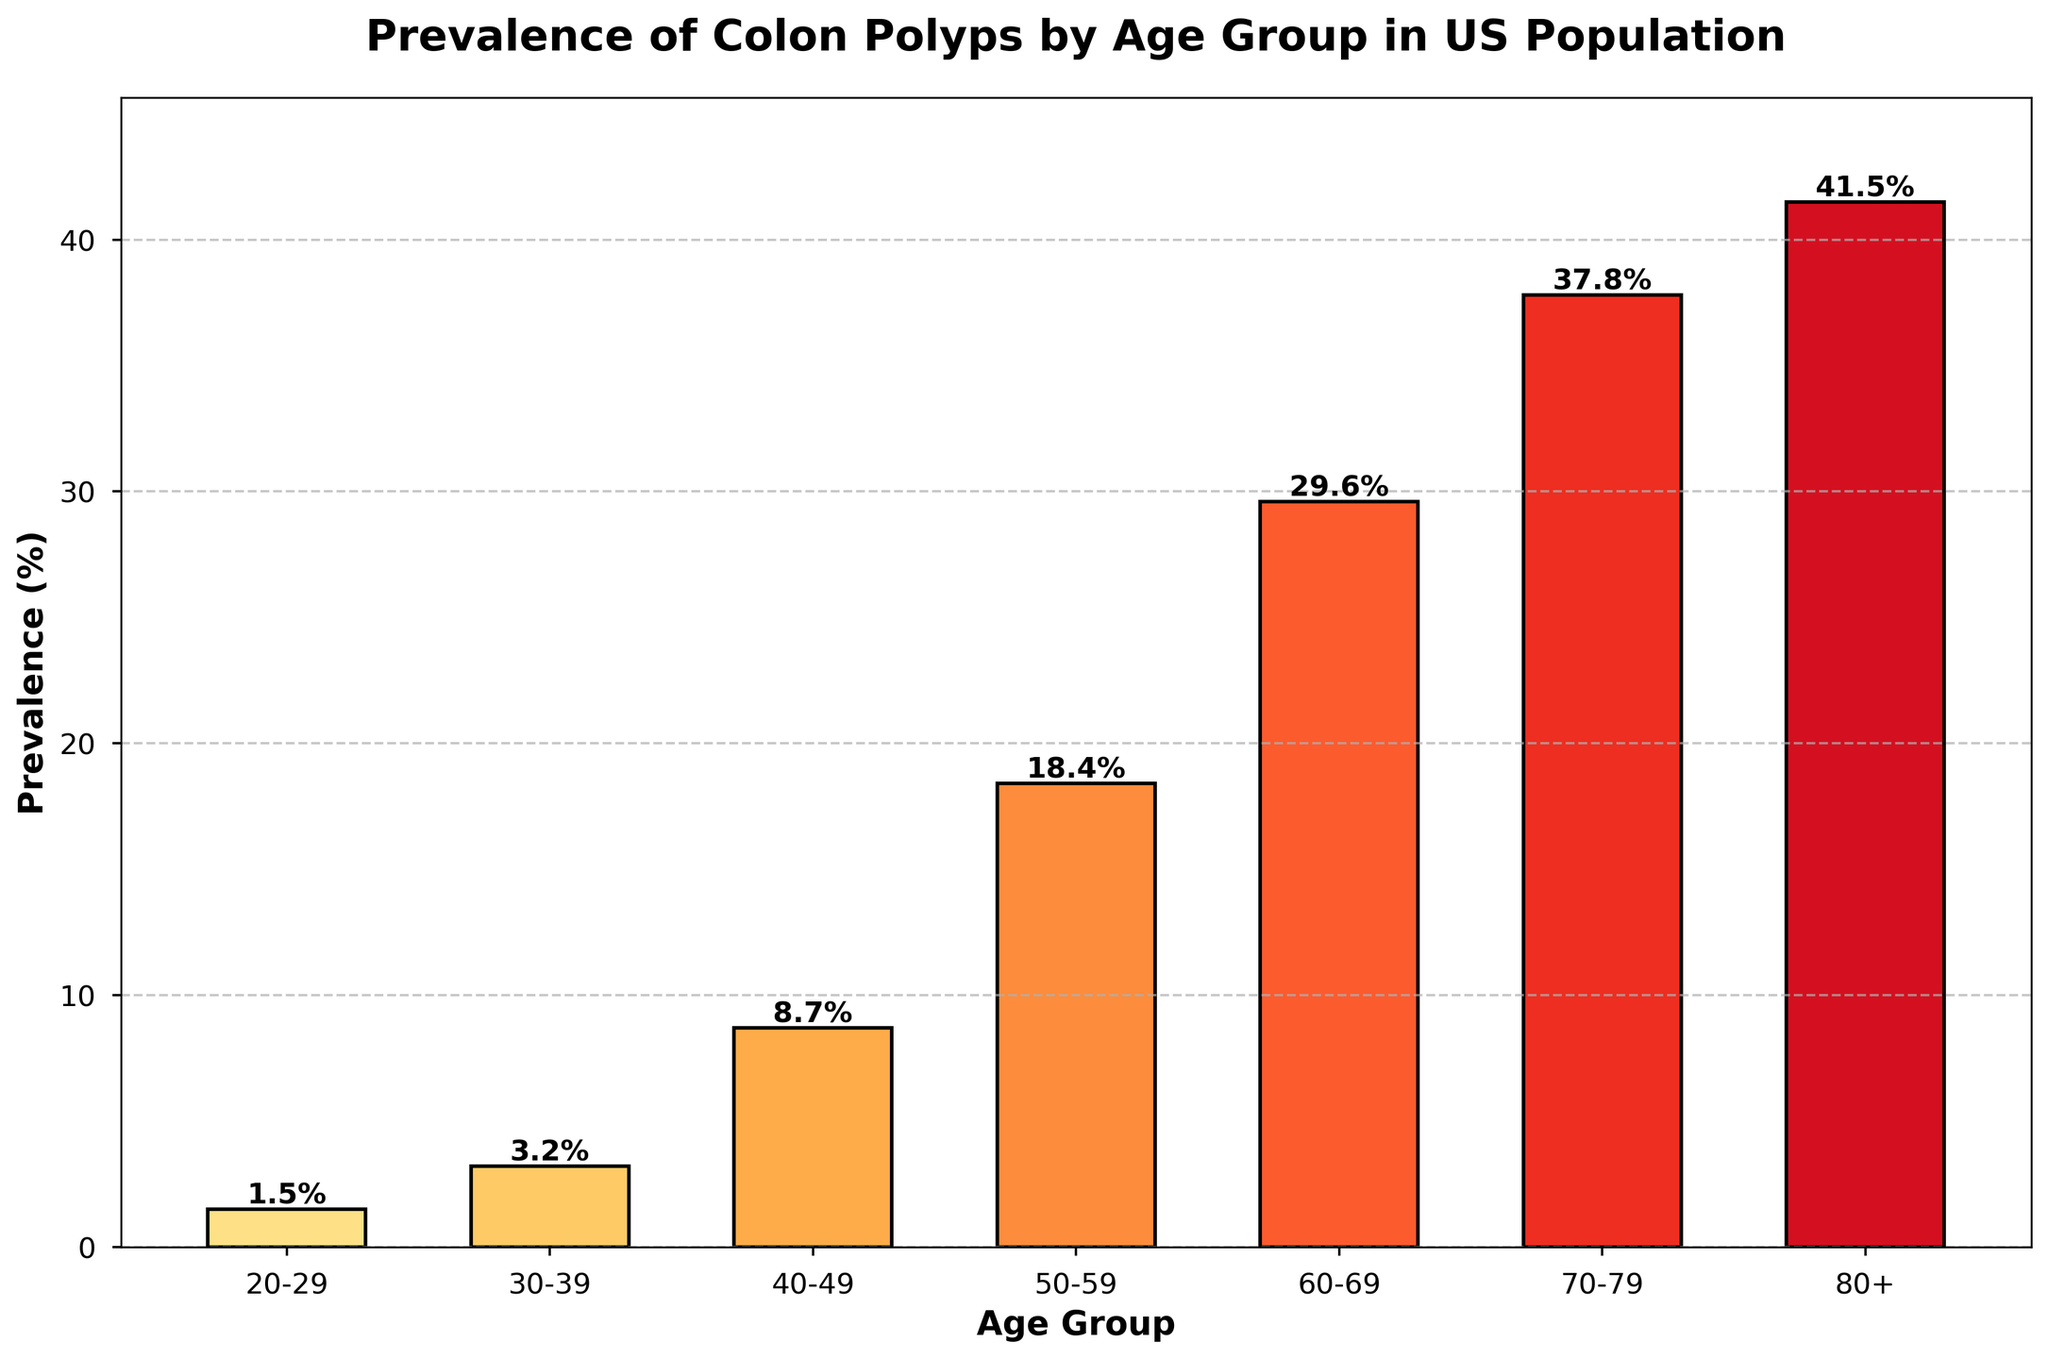What's the age group with the highest prevalence of colon polyps? The age group with the highest prevalence of colon polyps will have the tallest bar in the chart. By examining the chart, it's clear that the bar for the 80+ age group is the tallest, indicating the highest prevalence.
Answer: 80+ What's the difference in prevalence between the 40-49 and 50-59 age groups? To find the difference in prevalence, subtract the prevalence of the 40-49 age group from the 50-59 age group. The prevalence for 40-49 is 8.7%, and for 50-59, it is 18.4%. The difference is 18.4% - 8.7%.
Answer: 9.7% Which age group has a prevalence of colon polyps greater than 30%? An age group with a prevalence greater than 30% will have bars that extend above the 30% mark on the y-axis. By looking at the chart, the 70-79 and 80+ age groups have prevalence rates of 37.8% and 41.5%, respectively.
Answer: 70-79, 80+ What is the average prevalence of colon polyps for the age groups 60-69 and 70-79? To calculate the average prevalence, add the prevalence figures for the 60-69 and 70-79 age groups and divide by 2. The prevalences are 29.6% and 37.8%. The average is (29.6% + 37.8%) / 2.
Answer: 33.7% How many age groups have a prevalence less than 10%? Count the number of bars whose heights correspond to a prevalence figure below 10% on the y-axis. The age groups 20-29, 30-39, and 40-49 have prevalence values of 1.5%, 3.2%, and 8.7%, respectively.
Answer: 3 Which age group sees the sharpest increase in prevalence compared to the previous group? To determine the sharpest increase, look at the differences in prevalences between successive age groups and identify the largest difference. The prevalence increases are: 20-29 to 30-39 (1.7%), 30-39 to 40-49 (5.5%), 40-49 to 50-59 (9.7%), 50-59 to 60-69 (11.2%), 60-69 to 70-79 (8.2%), 70-79 to 80+ (3.7%). The sharpest increase is between the 50-59 and 60-69 age groups.
Answer: 50-59 to 60-69 What is the total prevalence for all age groups combined? Sum the prevalence percentages for all listed age groups. (1.5% + 3.2% + 8.7% + 18.4% + 29.6% + 37.8% + 41.5%) = 140.7%.
Answer: 140.7% What trend is visible in the prevalence of colon polyps as age increases? Observe the pattern of the heights of the bars as the age groups progress. The bars increase in height consistently from the youngest (20-29) to the oldest (80+), indicating that prevalence increases with age.
Answer: Increases 